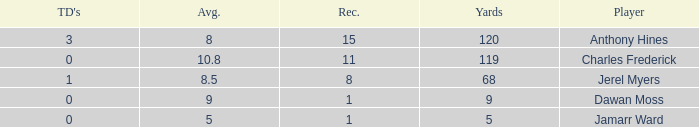What is the total Avg when TDs are 0 and Dawan Moss is a player? 0.0. 